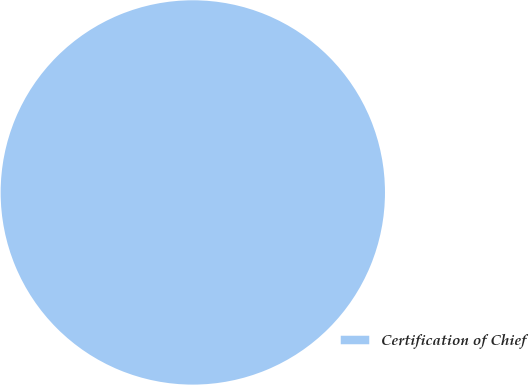Convert chart to OTSL. <chart><loc_0><loc_0><loc_500><loc_500><pie_chart><fcel>Certification of Chief<nl><fcel>100.0%<nl></chart> 